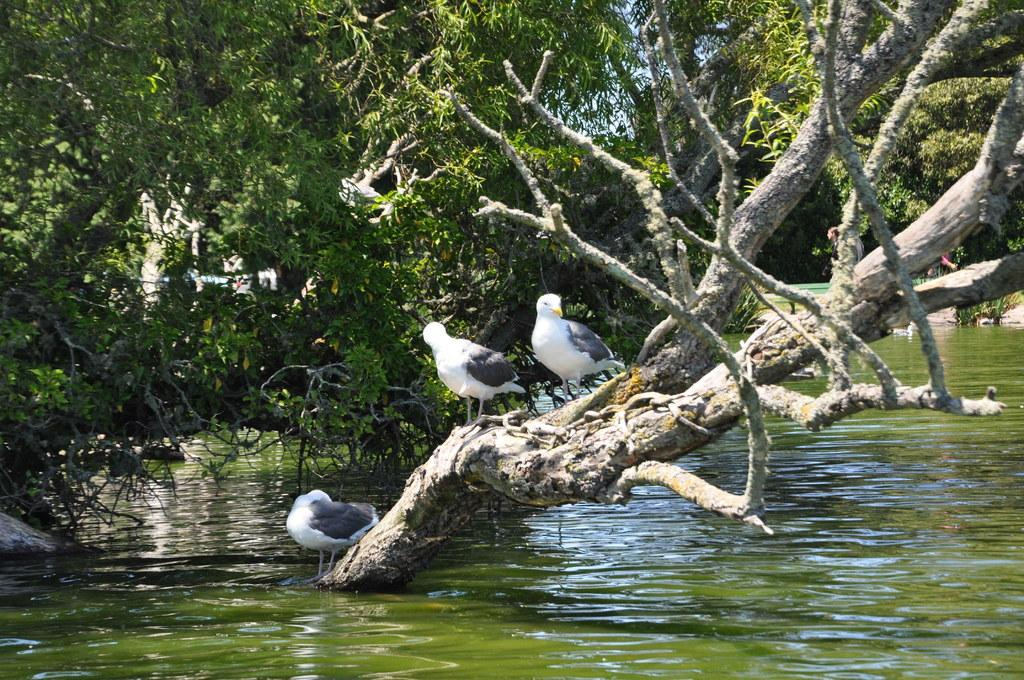What animals can be seen in the image? There are birds on a tree in the image. What type of vegetation is visible in the image? There are trees visible in the image. Can you describe the person in the image? There is a person behind the tree in the image. What is visible at the top of the image? The sky is visible at the top of the image. What is visible at the bottom of the image? There is water visible at the bottom of the image. How many boats are visible in the image? There are no boats present in the image. What type of material is the tree made of, and how does it fold? The image does not provide information about the material of the tree or its ability to fold. 